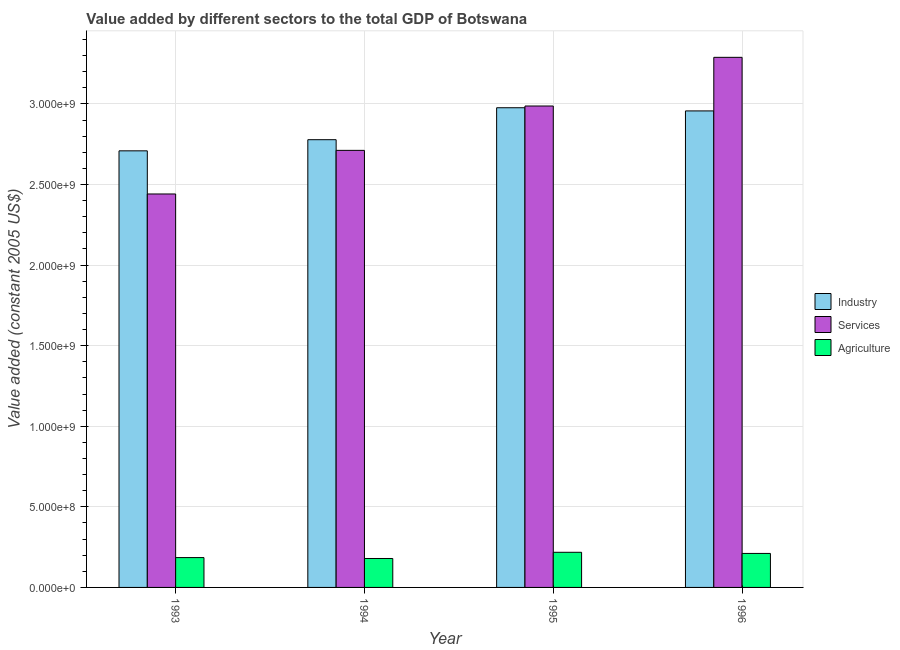How many groups of bars are there?
Provide a succinct answer. 4. Are the number of bars per tick equal to the number of legend labels?
Your response must be concise. Yes. How many bars are there on the 4th tick from the left?
Make the answer very short. 3. In how many cases, is the number of bars for a given year not equal to the number of legend labels?
Provide a succinct answer. 0. What is the value added by agricultural sector in 1993?
Your answer should be compact. 1.85e+08. Across all years, what is the maximum value added by agricultural sector?
Offer a very short reply. 2.18e+08. Across all years, what is the minimum value added by industrial sector?
Ensure brevity in your answer.  2.71e+09. In which year was the value added by agricultural sector maximum?
Your answer should be very brief. 1995. In which year was the value added by agricultural sector minimum?
Make the answer very short. 1994. What is the total value added by agricultural sector in the graph?
Provide a short and direct response. 7.94e+08. What is the difference between the value added by services in 1995 and that in 1996?
Provide a succinct answer. -3.02e+08. What is the difference between the value added by agricultural sector in 1993 and the value added by industrial sector in 1994?
Provide a succinct answer. 5.67e+06. What is the average value added by agricultural sector per year?
Keep it short and to the point. 1.98e+08. In the year 1993, what is the difference between the value added by industrial sector and value added by agricultural sector?
Provide a succinct answer. 0. What is the ratio of the value added by agricultural sector in 1995 to that in 1996?
Your response must be concise. 1.03. Is the value added by agricultural sector in 1994 less than that in 1995?
Offer a terse response. Yes. What is the difference between the highest and the second highest value added by agricultural sector?
Your response must be concise. 7.04e+06. What is the difference between the highest and the lowest value added by agricultural sector?
Keep it short and to the point. 3.85e+07. In how many years, is the value added by agricultural sector greater than the average value added by agricultural sector taken over all years?
Your answer should be very brief. 2. Is the sum of the value added by industrial sector in 1993 and 1994 greater than the maximum value added by services across all years?
Provide a succinct answer. Yes. What does the 3rd bar from the left in 1993 represents?
Offer a terse response. Agriculture. What does the 3rd bar from the right in 1996 represents?
Provide a succinct answer. Industry. Are all the bars in the graph horizontal?
Offer a very short reply. No. How many years are there in the graph?
Provide a short and direct response. 4. What is the difference between two consecutive major ticks on the Y-axis?
Offer a very short reply. 5.00e+08. Does the graph contain grids?
Offer a very short reply. Yes. What is the title of the graph?
Offer a terse response. Value added by different sectors to the total GDP of Botswana. What is the label or title of the Y-axis?
Make the answer very short. Value added (constant 2005 US$). What is the Value added (constant 2005 US$) in Industry in 1993?
Offer a very short reply. 2.71e+09. What is the Value added (constant 2005 US$) in Services in 1993?
Offer a very short reply. 2.44e+09. What is the Value added (constant 2005 US$) of Agriculture in 1993?
Ensure brevity in your answer.  1.85e+08. What is the Value added (constant 2005 US$) of Industry in 1994?
Provide a short and direct response. 2.78e+09. What is the Value added (constant 2005 US$) in Services in 1994?
Offer a very short reply. 2.71e+09. What is the Value added (constant 2005 US$) of Agriculture in 1994?
Offer a terse response. 1.79e+08. What is the Value added (constant 2005 US$) in Industry in 1995?
Offer a terse response. 2.98e+09. What is the Value added (constant 2005 US$) in Services in 1995?
Provide a succinct answer. 2.99e+09. What is the Value added (constant 2005 US$) of Agriculture in 1995?
Your answer should be compact. 2.18e+08. What is the Value added (constant 2005 US$) in Industry in 1996?
Provide a short and direct response. 2.96e+09. What is the Value added (constant 2005 US$) in Services in 1996?
Keep it short and to the point. 3.29e+09. What is the Value added (constant 2005 US$) of Agriculture in 1996?
Your answer should be compact. 2.11e+08. Across all years, what is the maximum Value added (constant 2005 US$) in Industry?
Offer a very short reply. 2.98e+09. Across all years, what is the maximum Value added (constant 2005 US$) in Services?
Ensure brevity in your answer.  3.29e+09. Across all years, what is the maximum Value added (constant 2005 US$) of Agriculture?
Make the answer very short. 2.18e+08. Across all years, what is the minimum Value added (constant 2005 US$) of Industry?
Offer a terse response. 2.71e+09. Across all years, what is the minimum Value added (constant 2005 US$) of Services?
Give a very brief answer. 2.44e+09. Across all years, what is the minimum Value added (constant 2005 US$) of Agriculture?
Make the answer very short. 1.79e+08. What is the total Value added (constant 2005 US$) of Industry in the graph?
Offer a terse response. 1.14e+1. What is the total Value added (constant 2005 US$) in Services in the graph?
Provide a short and direct response. 1.14e+1. What is the total Value added (constant 2005 US$) of Agriculture in the graph?
Provide a short and direct response. 7.94e+08. What is the difference between the Value added (constant 2005 US$) of Industry in 1993 and that in 1994?
Your answer should be compact. -6.92e+07. What is the difference between the Value added (constant 2005 US$) in Services in 1993 and that in 1994?
Your answer should be very brief. -2.71e+08. What is the difference between the Value added (constant 2005 US$) of Agriculture in 1993 and that in 1994?
Provide a succinct answer. 5.67e+06. What is the difference between the Value added (constant 2005 US$) in Industry in 1993 and that in 1995?
Give a very brief answer. -2.67e+08. What is the difference between the Value added (constant 2005 US$) in Services in 1993 and that in 1995?
Your response must be concise. -5.46e+08. What is the difference between the Value added (constant 2005 US$) in Agriculture in 1993 and that in 1995?
Your answer should be compact. -3.28e+07. What is the difference between the Value added (constant 2005 US$) of Industry in 1993 and that in 1996?
Your answer should be very brief. -2.48e+08. What is the difference between the Value added (constant 2005 US$) in Services in 1993 and that in 1996?
Make the answer very short. -8.48e+08. What is the difference between the Value added (constant 2005 US$) in Agriculture in 1993 and that in 1996?
Provide a succinct answer. -2.58e+07. What is the difference between the Value added (constant 2005 US$) of Industry in 1994 and that in 1995?
Offer a terse response. -1.98e+08. What is the difference between the Value added (constant 2005 US$) in Services in 1994 and that in 1995?
Your answer should be very brief. -2.75e+08. What is the difference between the Value added (constant 2005 US$) in Agriculture in 1994 and that in 1995?
Your answer should be compact. -3.85e+07. What is the difference between the Value added (constant 2005 US$) of Industry in 1994 and that in 1996?
Offer a very short reply. -1.79e+08. What is the difference between the Value added (constant 2005 US$) in Services in 1994 and that in 1996?
Keep it short and to the point. -5.77e+08. What is the difference between the Value added (constant 2005 US$) of Agriculture in 1994 and that in 1996?
Provide a succinct answer. -3.15e+07. What is the difference between the Value added (constant 2005 US$) of Industry in 1995 and that in 1996?
Offer a terse response. 1.96e+07. What is the difference between the Value added (constant 2005 US$) of Services in 1995 and that in 1996?
Offer a very short reply. -3.02e+08. What is the difference between the Value added (constant 2005 US$) in Agriculture in 1995 and that in 1996?
Ensure brevity in your answer.  7.04e+06. What is the difference between the Value added (constant 2005 US$) of Industry in 1993 and the Value added (constant 2005 US$) of Services in 1994?
Provide a short and direct response. -2.88e+06. What is the difference between the Value added (constant 2005 US$) of Industry in 1993 and the Value added (constant 2005 US$) of Agriculture in 1994?
Ensure brevity in your answer.  2.53e+09. What is the difference between the Value added (constant 2005 US$) in Services in 1993 and the Value added (constant 2005 US$) in Agriculture in 1994?
Provide a short and direct response. 2.26e+09. What is the difference between the Value added (constant 2005 US$) in Industry in 1993 and the Value added (constant 2005 US$) in Services in 1995?
Offer a very short reply. -2.78e+08. What is the difference between the Value added (constant 2005 US$) of Industry in 1993 and the Value added (constant 2005 US$) of Agriculture in 1995?
Provide a short and direct response. 2.49e+09. What is the difference between the Value added (constant 2005 US$) of Services in 1993 and the Value added (constant 2005 US$) of Agriculture in 1995?
Offer a terse response. 2.22e+09. What is the difference between the Value added (constant 2005 US$) in Industry in 1993 and the Value added (constant 2005 US$) in Services in 1996?
Give a very brief answer. -5.80e+08. What is the difference between the Value added (constant 2005 US$) of Industry in 1993 and the Value added (constant 2005 US$) of Agriculture in 1996?
Give a very brief answer. 2.50e+09. What is the difference between the Value added (constant 2005 US$) in Services in 1993 and the Value added (constant 2005 US$) in Agriculture in 1996?
Give a very brief answer. 2.23e+09. What is the difference between the Value added (constant 2005 US$) of Industry in 1994 and the Value added (constant 2005 US$) of Services in 1995?
Provide a short and direct response. -2.09e+08. What is the difference between the Value added (constant 2005 US$) of Industry in 1994 and the Value added (constant 2005 US$) of Agriculture in 1995?
Your response must be concise. 2.56e+09. What is the difference between the Value added (constant 2005 US$) in Services in 1994 and the Value added (constant 2005 US$) in Agriculture in 1995?
Your answer should be very brief. 2.49e+09. What is the difference between the Value added (constant 2005 US$) in Industry in 1994 and the Value added (constant 2005 US$) in Services in 1996?
Provide a succinct answer. -5.11e+08. What is the difference between the Value added (constant 2005 US$) in Industry in 1994 and the Value added (constant 2005 US$) in Agriculture in 1996?
Keep it short and to the point. 2.57e+09. What is the difference between the Value added (constant 2005 US$) in Services in 1994 and the Value added (constant 2005 US$) in Agriculture in 1996?
Make the answer very short. 2.50e+09. What is the difference between the Value added (constant 2005 US$) in Industry in 1995 and the Value added (constant 2005 US$) in Services in 1996?
Offer a terse response. -3.13e+08. What is the difference between the Value added (constant 2005 US$) in Industry in 1995 and the Value added (constant 2005 US$) in Agriculture in 1996?
Ensure brevity in your answer.  2.77e+09. What is the difference between the Value added (constant 2005 US$) of Services in 1995 and the Value added (constant 2005 US$) of Agriculture in 1996?
Keep it short and to the point. 2.78e+09. What is the average Value added (constant 2005 US$) of Industry per year?
Offer a very short reply. 2.85e+09. What is the average Value added (constant 2005 US$) of Services per year?
Your response must be concise. 2.86e+09. What is the average Value added (constant 2005 US$) in Agriculture per year?
Provide a short and direct response. 1.98e+08. In the year 1993, what is the difference between the Value added (constant 2005 US$) of Industry and Value added (constant 2005 US$) of Services?
Your answer should be compact. 2.68e+08. In the year 1993, what is the difference between the Value added (constant 2005 US$) of Industry and Value added (constant 2005 US$) of Agriculture?
Offer a very short reply. 2.52e+09. In the year 1993, what is the difference between the Value added (constant 2005 US$) of Services and Value added (constant 2005 US$) of Agriculture?
Make the answer very short. 2.26e+09. In the year 1994, what is the difference between the Value added (constant 2005 US$) of Industry and Value added (constant 2005 US$) of Services?
Offer a very short reply. 6.63e+07. In the year 1994, what is the difference between the Value added (constant 2005 US$) of Industry and Value added (constant 2005 US$) of Agriculture?
Your answer should be compact. 2.60e+09. In the year 1994, what is the difference between the Value added (constant 2005 US$) in Services and Value added (constant 2005 US$) in Agriculture?
Your answer should be very brief. 2.53e+09. In the year 1995, what is the difference between the Value added (constant 2005 US$) in Industry and Value added (constant 2005 US$) in Services?
Your answer should be compact. -1.08e+07. In the year 1995, what is the difference between the Value added (constant 2005 US$) in Industry and Value added (constant 2005 US$) in Agriculture?
Provide a succinct answer. 2.76e+09. In the year 1995, what is the difference between the Value added (constant 2005 US$) of Services and Value added (constant 2005 US$) of Agriculture?
Your answer should be very brief. 2.77e+09. In the year 1996, what is the difference between the Value added (constant 2005 US$) of Industry and Value added (constant 2005 US$) of Services?
Provide a short and direct response. -3.32e+08. In the year 1996, what is the difference between the Value added (constant 2005 US$) of Industry and Value added (constant 2005 US$) of Agriculture?
Make the answer very short. 2.75e+09. In the year 1996, what is the difference between the Value added (constant 2005 US$) in Services and Value added (constant 2005 US$) in Agriculture?
Keep it short and to the point. 3.08e+09. What is the ratio of the Value added (constant 2005 US$) in Industry in 1993 to that in 1994?
Your answer should be very brief. 0.98. What is the ratio of the Value added (constant 2005 US$) in Services in 1993 to that in 1994?
Your response must be concise. 0.9. What is the ratio of the Value added (constant 2005 US$) in Agriculture in 1993 to that in 1994?
Make the answer very short. 1.03. What is the ratio of the Value added (constant 2005 US$) in Industry in 1993 to that in 1995?
Give a very brief answer. 0.91. What is the ratio of the Value added (constant 2005 US$) in Services in 1993 to that in 1995?
Offer a very short reply. 0.82. What is the ratio of the Value added (constant 2005 US$) in Agriculture in 1993 to that in 1995?
Your answer should be compact. 0.85. What is the ratio of the Value added (constant 2005 US$) in Industry in 1993 to that in 1996?
Provide a short and direct response. 0.92. What is the ratio of the Value added (constant 2005 US$) of Services in 1993 to that in 1996?
Provide a succinct answer. 0.74. What is the ratio of the Value added (constant 2005 US$) of Agriculture in 1993 to that in 1996?
Make the answer very short. 0.88. What is the ratio of the Value added (constant 2005 US$) in Industry in 1994 to that in 1995?
Your answer should be compact. 0.93. What is the ratio of the Value added (constant 2005 US$) in Services in 1994 to that in 1995?
Provide a short and direct response. 0.91. What is the ratio of the Value added (constant 2005 US$) of Agriculture in 1994 to that in 1995?
Your response must be concise. 0.82. What is the ratio of the Value added (constant 2005 US$) of Industry in 1994 to that in 1996?
Provide a short and direct response. 0.94. What is the ratio of the Value added (constant 2005 US$) of Services in 1994 to that in 1996?
Offer a terse response. 0.82. What is the ratio of the Value added (constant 2005 US$) in Agriculture in 1994 to that in 1996?
Keep it short and to the point. 0.85. What is the ratio of the Value added (constant 2005 US$) of Industry in 1995 to that in 1996?
Ensure brevity in your answer.  1.01. What is the ratio of the Value added (constant 2005 US$) of Services in 1995 to that in 1996?
Provide a short and direct response. 0.91. What is the ratio of the Value added (constant 2005 US$) in Agriculture in 1995 to that in 1996?
Your answer should be compact. 1.03. What is the difference between the highest and the second highest Value added (constant 2005 US$) in Industry?
Ensure brevity in your answer.  1.96e+07. What is the difference between the highest and the second highest Value added (constant 2005 US$) in Services?
Your response must be concise. 3.02e+08. What is the difference between the highest and the second highest Value added (constant 2005 US$) in Agriculture?
Your answer should be very brief. 7.04e+06. What is the difference between the highest and the lowest Value added (constant 2005 US$) of Industry?
Give a very brief answer. 2.67e+08. What is the difference between the highest and the lowest Value added (constant 2005 US$) in Services?
Make the answer very short. 8.48e+08. What is the difference between the highest and the lowest Value added (constant 2005 US$) in Agriculture?
Offer a terse response. 3.85e+07. 